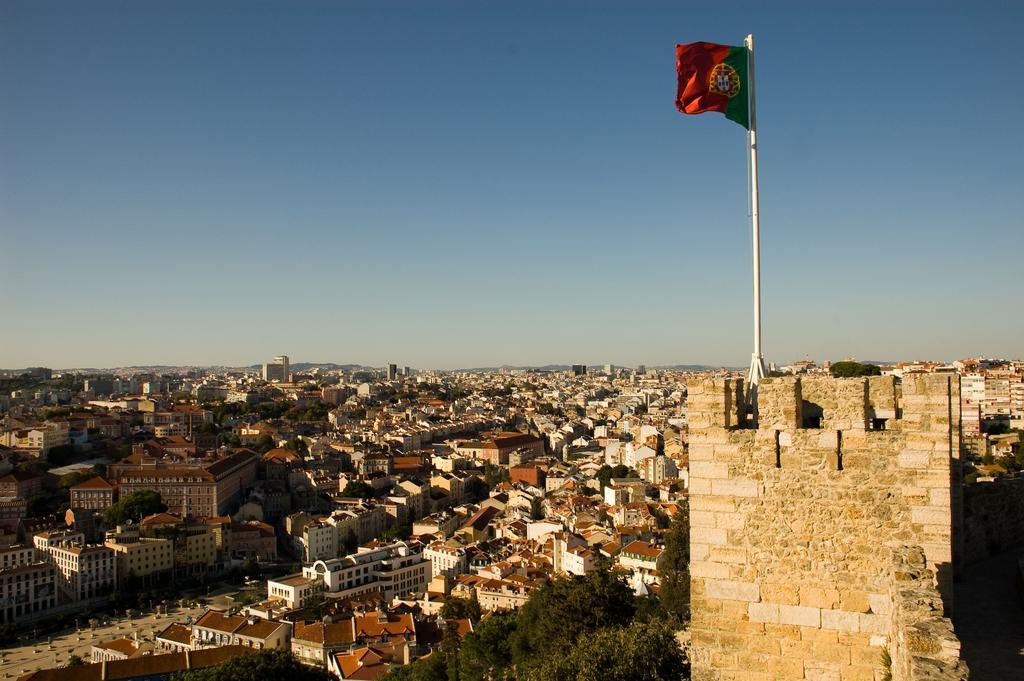How would you summarize this image in a sentence or two? In this image I can see houses, buildings, trees, flagpole, vehicles on the road and the sky. This image is taken may be during a sunny day. 